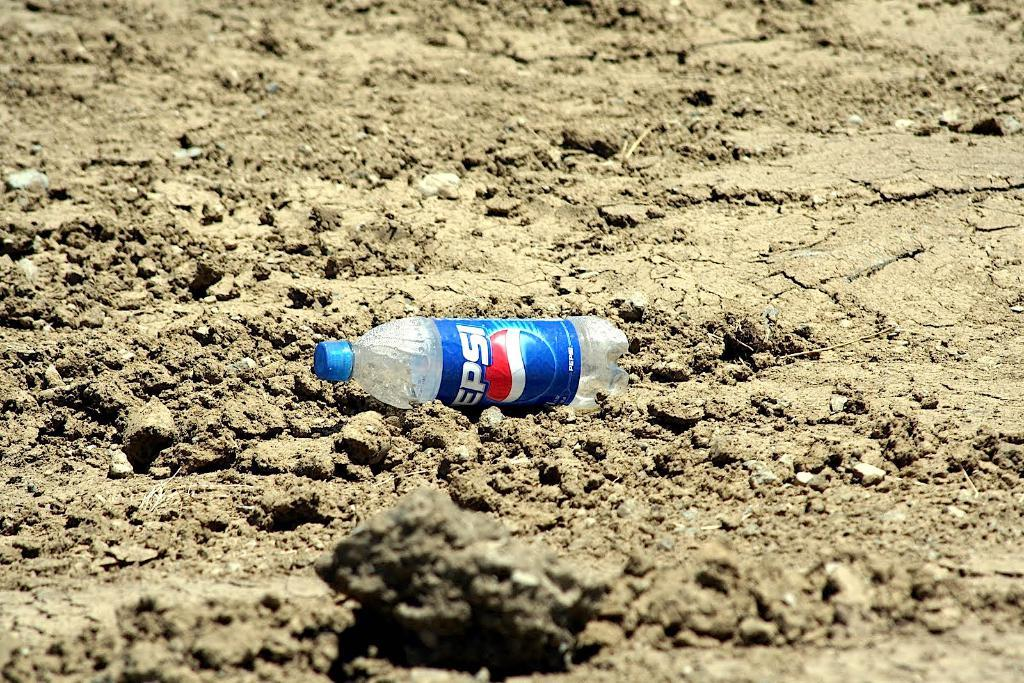<image>
Create a compact narrative representing the image presented. an empty bottle of pepsi laying in sand 